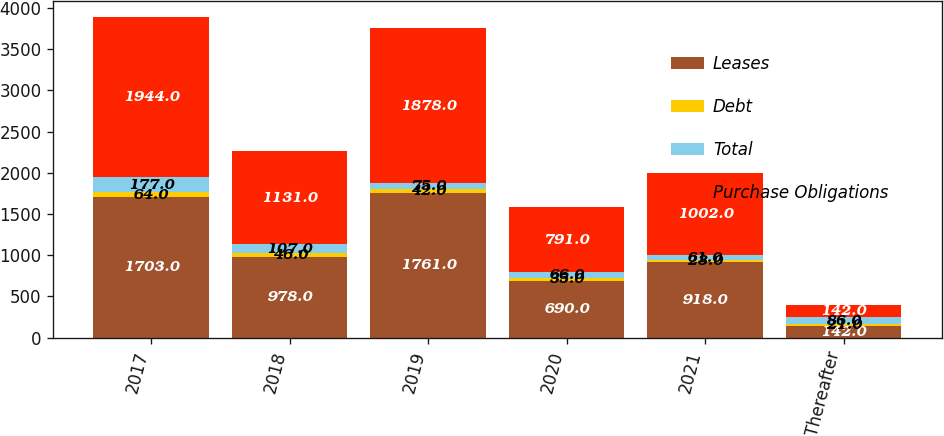Convert chart. <chart><loc_0><loc_0><loc_500><loc_500><stacked_bar_chart><ecel><fcel>2017<fcel>2018<fcel>2019<fcel>2020<fcel>2021<fcel>Thereafter<nl><fcel>Leases<fcel>1703<fcel>978<fcel>1761<fcel>690<fcel>918<fcel>142<nl><fcel>Debt<fcel>64<fcel>46<fcel>42<fcel>35<fcel>23<fcel>21<nl><fcel>Total<fcel>177<fcel>107<fcel>75<fcel>66<fcel>61<fcel>86<nl><fcel>Purchase Obligations<fcel>1944<fcel>1131<fcel>1878<fcel>791<fcel>1002<fcel>142<nl></chart> 